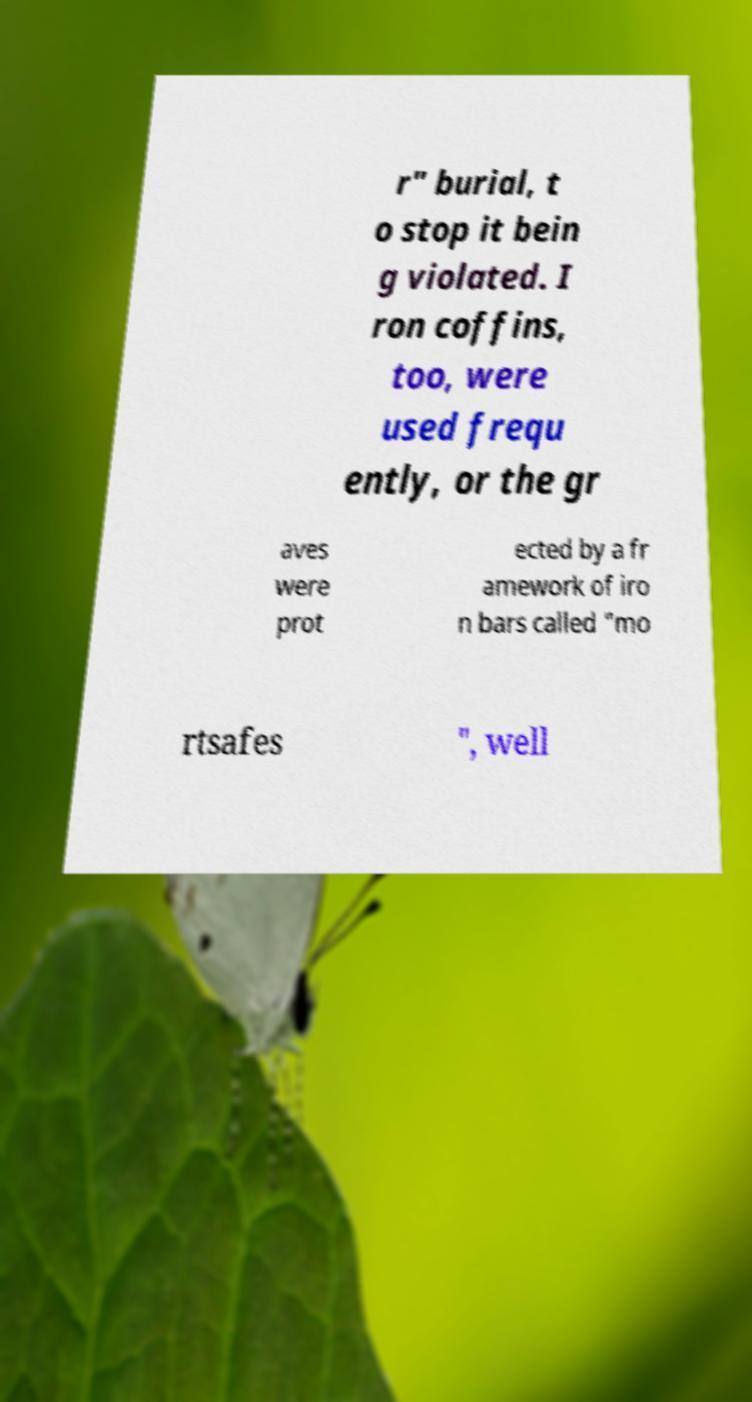What messages or text are displayed in this image? I need them in a readable, typed format. r" burial, t o stop it bein g violated. I ron coffins, too, were used frequ ently, or the gr aves were prot ected by a fr amework of iro n bars called "mo rtsafes ", well 